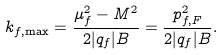Convert formula to latex. <formula><loc_0><loc_0><loc_500><loc_500>k _ { f , \max } = \frac { \mu _ { f } ^ { 2 } - M ^ { 2 } } { 2 | q _ { f } | B } = \frac { p _ { f , F } ^ { 2 } } { 2 | q _ { f } | B } .</formula> 